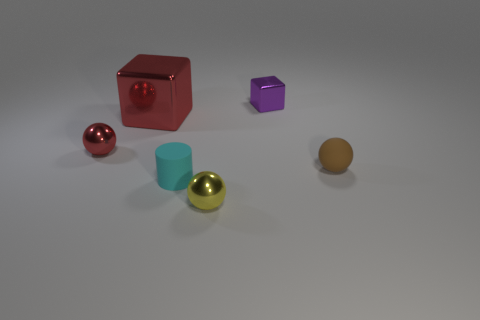Do the metallic sphere on the right side of the big block and the metallic block in front of the small purple cube have the same size?
Ensure brevity in your answer.  No. What number of balls are either yellow objects or small gray objects?
Provide a succinct answer. 1. Are the sphere that is on the left side of the large metal cube and the small yellow thing made of the same material?
Your answer should be compact. Yes. What number of other objects are there of the same size as the brown sphere?
Ensure brevity in your answer.  4. What number of large things are cyan matte cylinders or green rubber objects?
Offer a very short reply. 0. Is the tiny matte cylinder the same color as the rubber ball?
Keep it short and to the point. No. Is the number of small brown things on the left side of the yellow metallic ball greater than the number of red balls that are on the right side of the large block?
Give a very brief answer. No. There is a small thing to the left of the rubber cylinder; is it the same color as the tiny shiny block?
Offer a very short reply. No. Is there any other thing that is the same color as the small matte sphere?
Keep it short and to the point. No. Is the number of small brown things left of the large red thing greater than the number of red balls?
Offer a very short reply. No. 